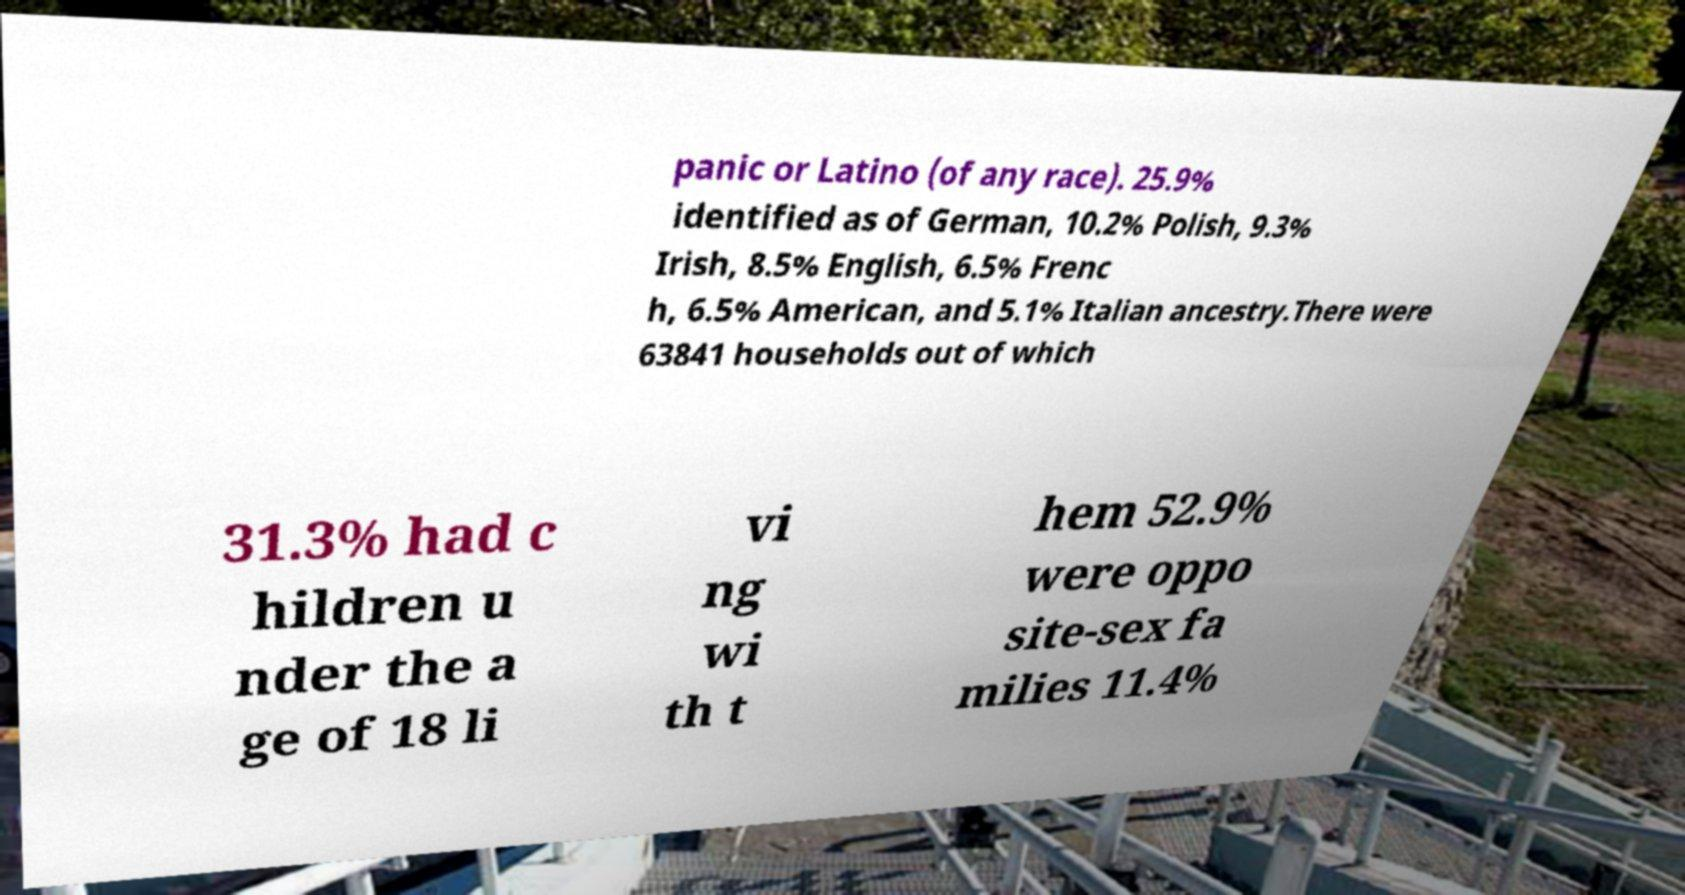Please identify and transcribe the text found in this image. panic or Latino (of any race). 25.9% identified as of German, 10.2% Polish, 9.3% Irish, 8.5% English, 6.5% Frenc h, 6.5% American, and 5.1% Italian ancestry.There were 63841 households out of which 31.3% had c hildren u nder the a ge of 18 li vi ng wi th t hem 52.9% were oppo site-sex fa milies 11.4% 